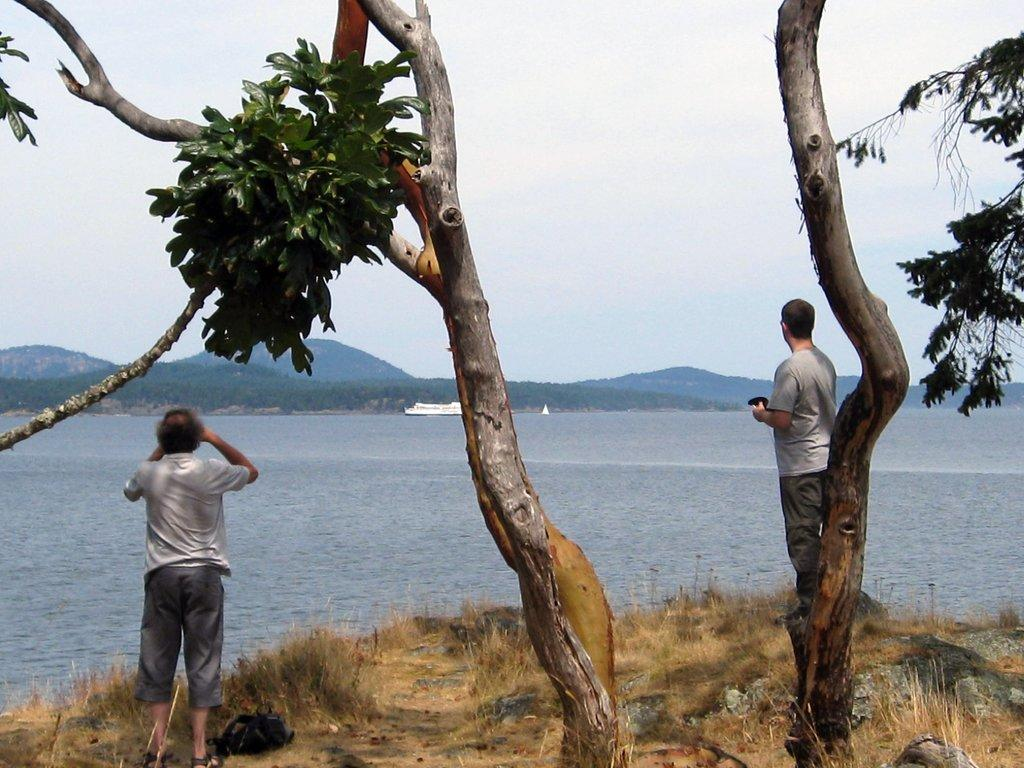How many people are in the image? There are two persons standing in the image. What is between the two persons? There is a tree between the two persons. What can be seen in the water in the image? A ship is present on the water. What type of natural environment is visible in the background of the image? There are trees and mountains in the background of the image. What type of treatment is being administered to the tree in the image? There is no treatment being administered to the tree in the image; it is a natural tree standing between the two persons. 